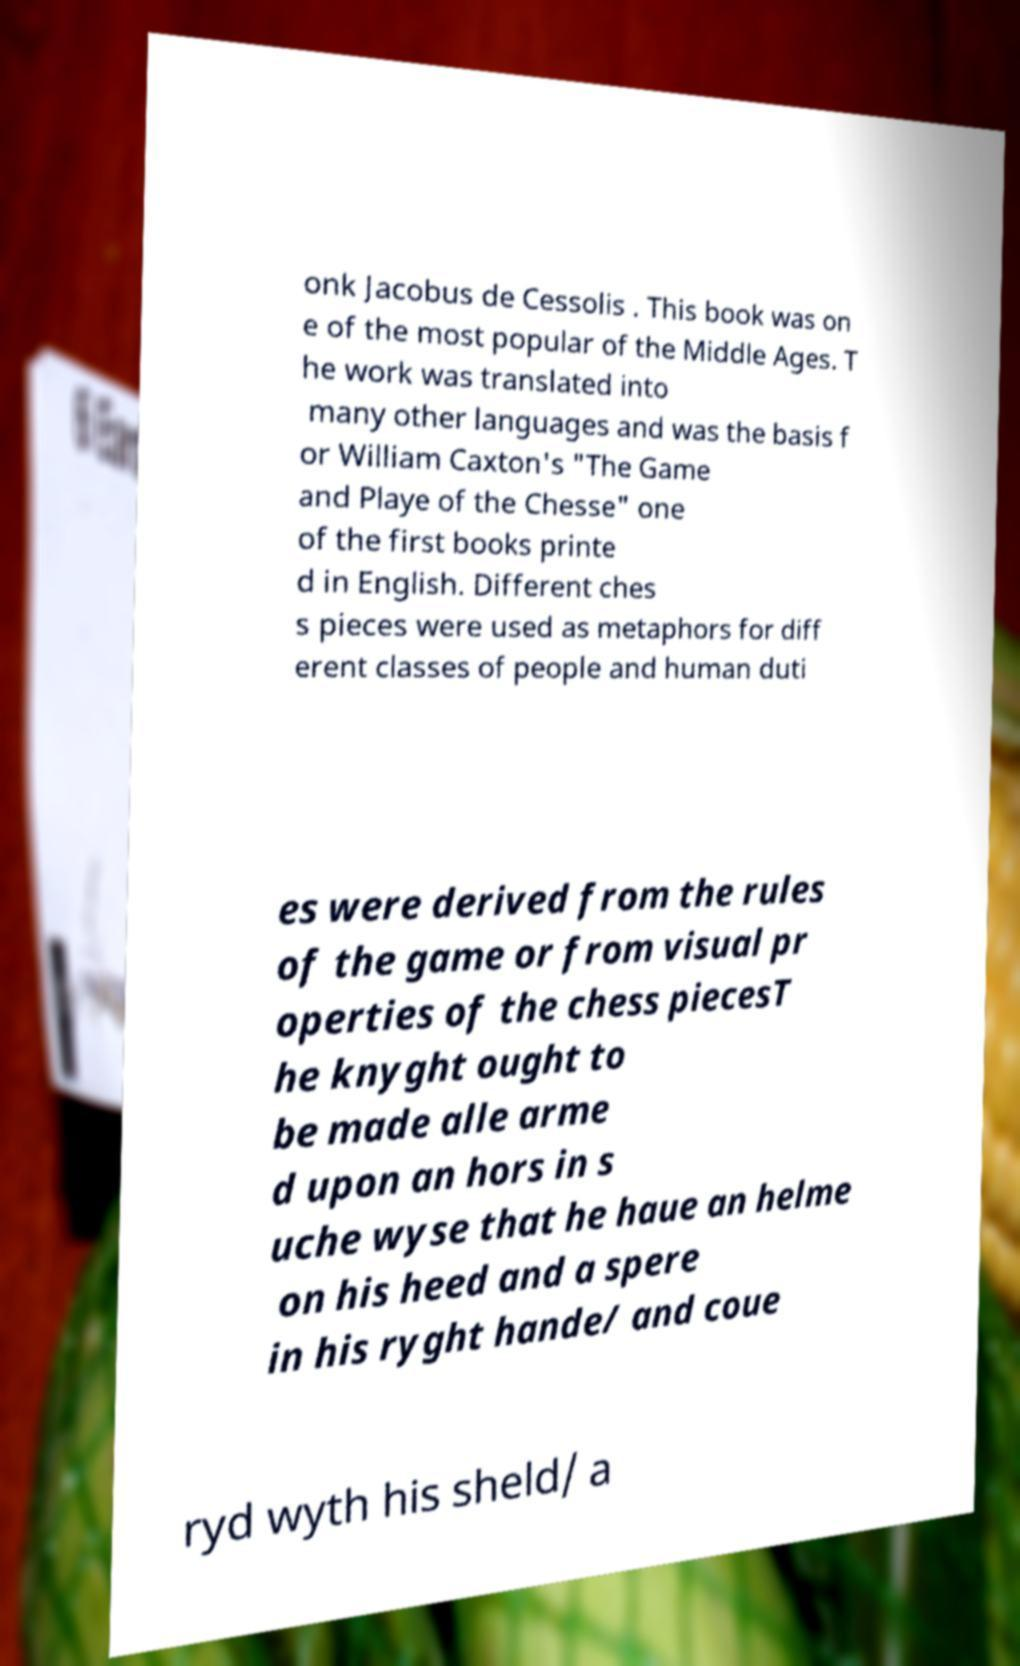Can you read and provide the text displayed in the image?This photo seems to have some interesting text. Can you extract and type it out for me? onk Jacobus de Cessolis . This book was on e of the most popular of the Middle Ages. T he work was translated into many other languages and was the basis f or William Caxton's "The Game and Playe of the Chesse" one of the first books printe d in English. Different ches s pieces were used as metaphors for diff erent classes of people and human duti es were derived from the rules of the game or from visual pr operties of the chess piecesT he knyght ought to be made alle arme d upon an hors in s uche wyse that he haue an helme on his heed and a spere in his ryght hande/ and coue ryd wyth his sheld/ a 